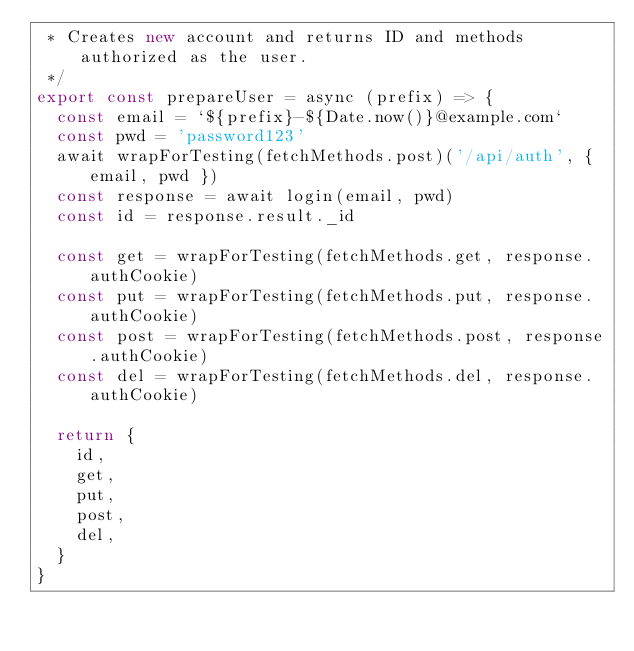Convert code to text. <code><loc_0><loc_0><loc_500><loc_500><_JavaScript_> * Creates new account and returns ID and methods authorized as the user.
 */
export const prepareUser = async (prefix) => {
  const email = `${prefix}-${Date.now()}@example.com`
  const pwd = 'password123'
  await wrapForTesting(fetchMethods.post)('/api/auth', { email, pwd })
  const response = await login(email, pwd)
  const id = response.result._id

  const get = wrapForTesting(fetchMethods.get, response.authCookie)
  const put = wrapForTesting(fetchMethods.put, response.authCookie)
  const post = wrapForTesting(fetchMethods.post, response.authCookie)
  const del = wrapForTesting(fetchMethods.del, response.authCookie)

  return {
    id,
    get,
    put,
    post,
    del,
  }
}
</code> 